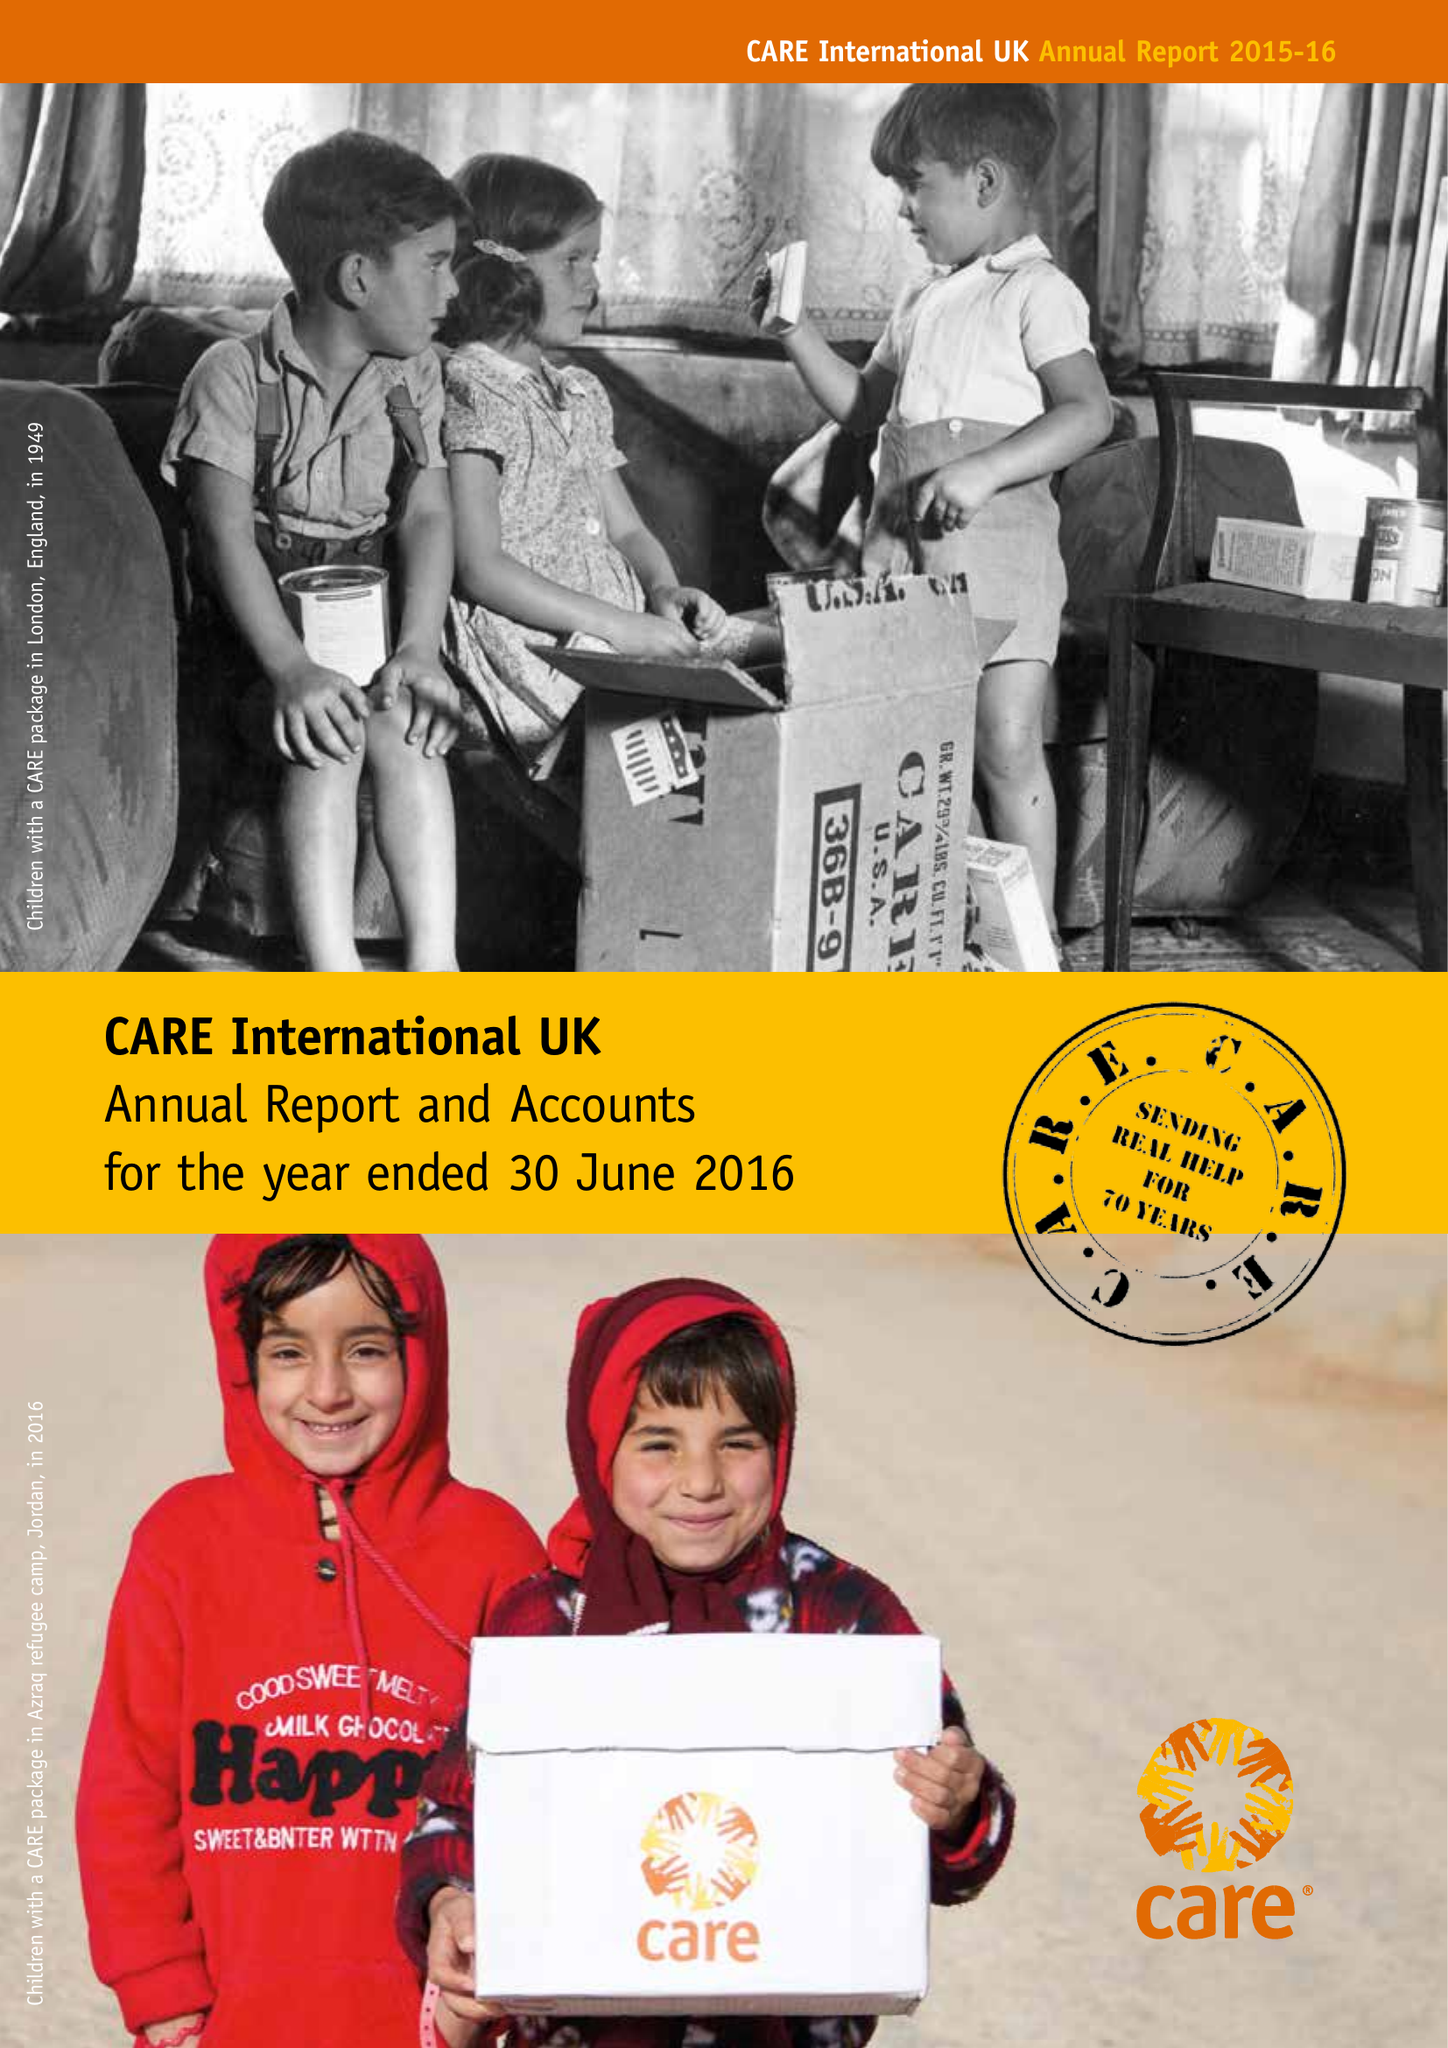What is the value for the address__postcode?
Answer the question using a single word or phrase. SE1 7TP 